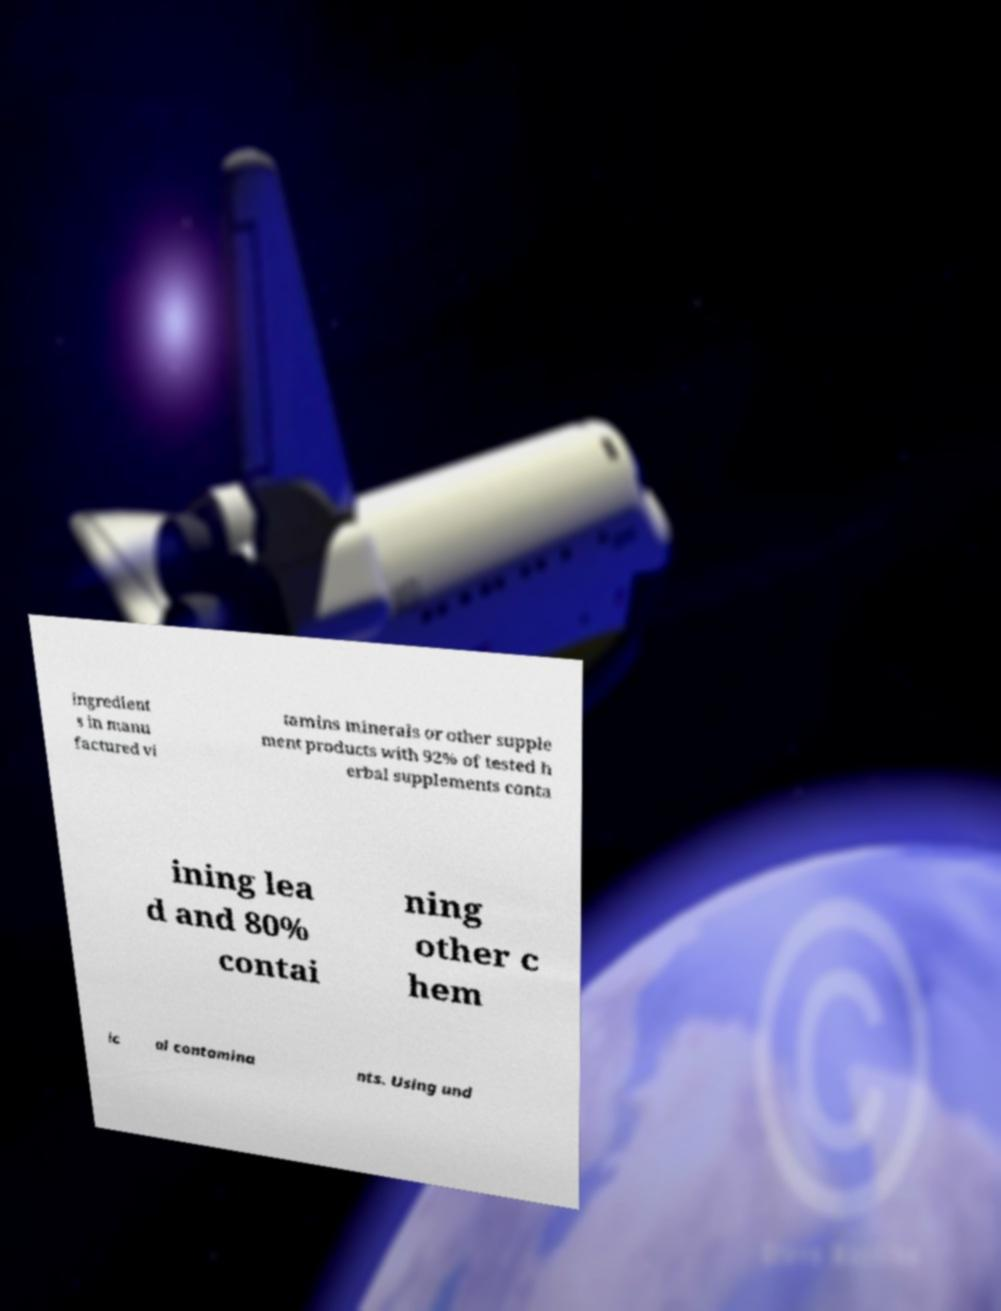Can you accurately transcribe the text from the provided image for me? ingredient s in manu factured vi tamins minerals or other supple ment products with 92% of tested h erbal supplements conta ining lea d and 80% contai ning other c hem ic al contamina nts. Using und 